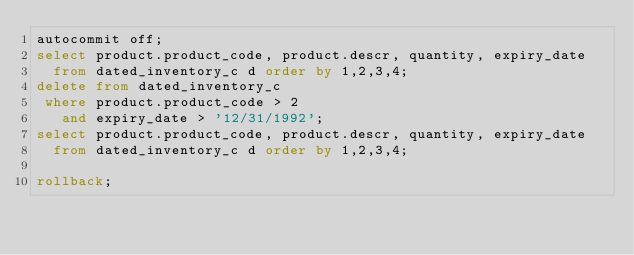<code> <loc_0><loc_0><loc_500><loc_500><_SQL_>autocommit off;
select product.product_code, product.descr, quantity, expiry_date
  from dated_inventory_c d order by 1,2,3,4;
delete from dated_inventory_c
 where product.product_code > 2
   and expiry_date > '12/31/1992';
select product.product_code, product.descr, quantity, expiry_date
  from dated_inventory_c d order by 1,2,3,4;

rollback;
</code> 